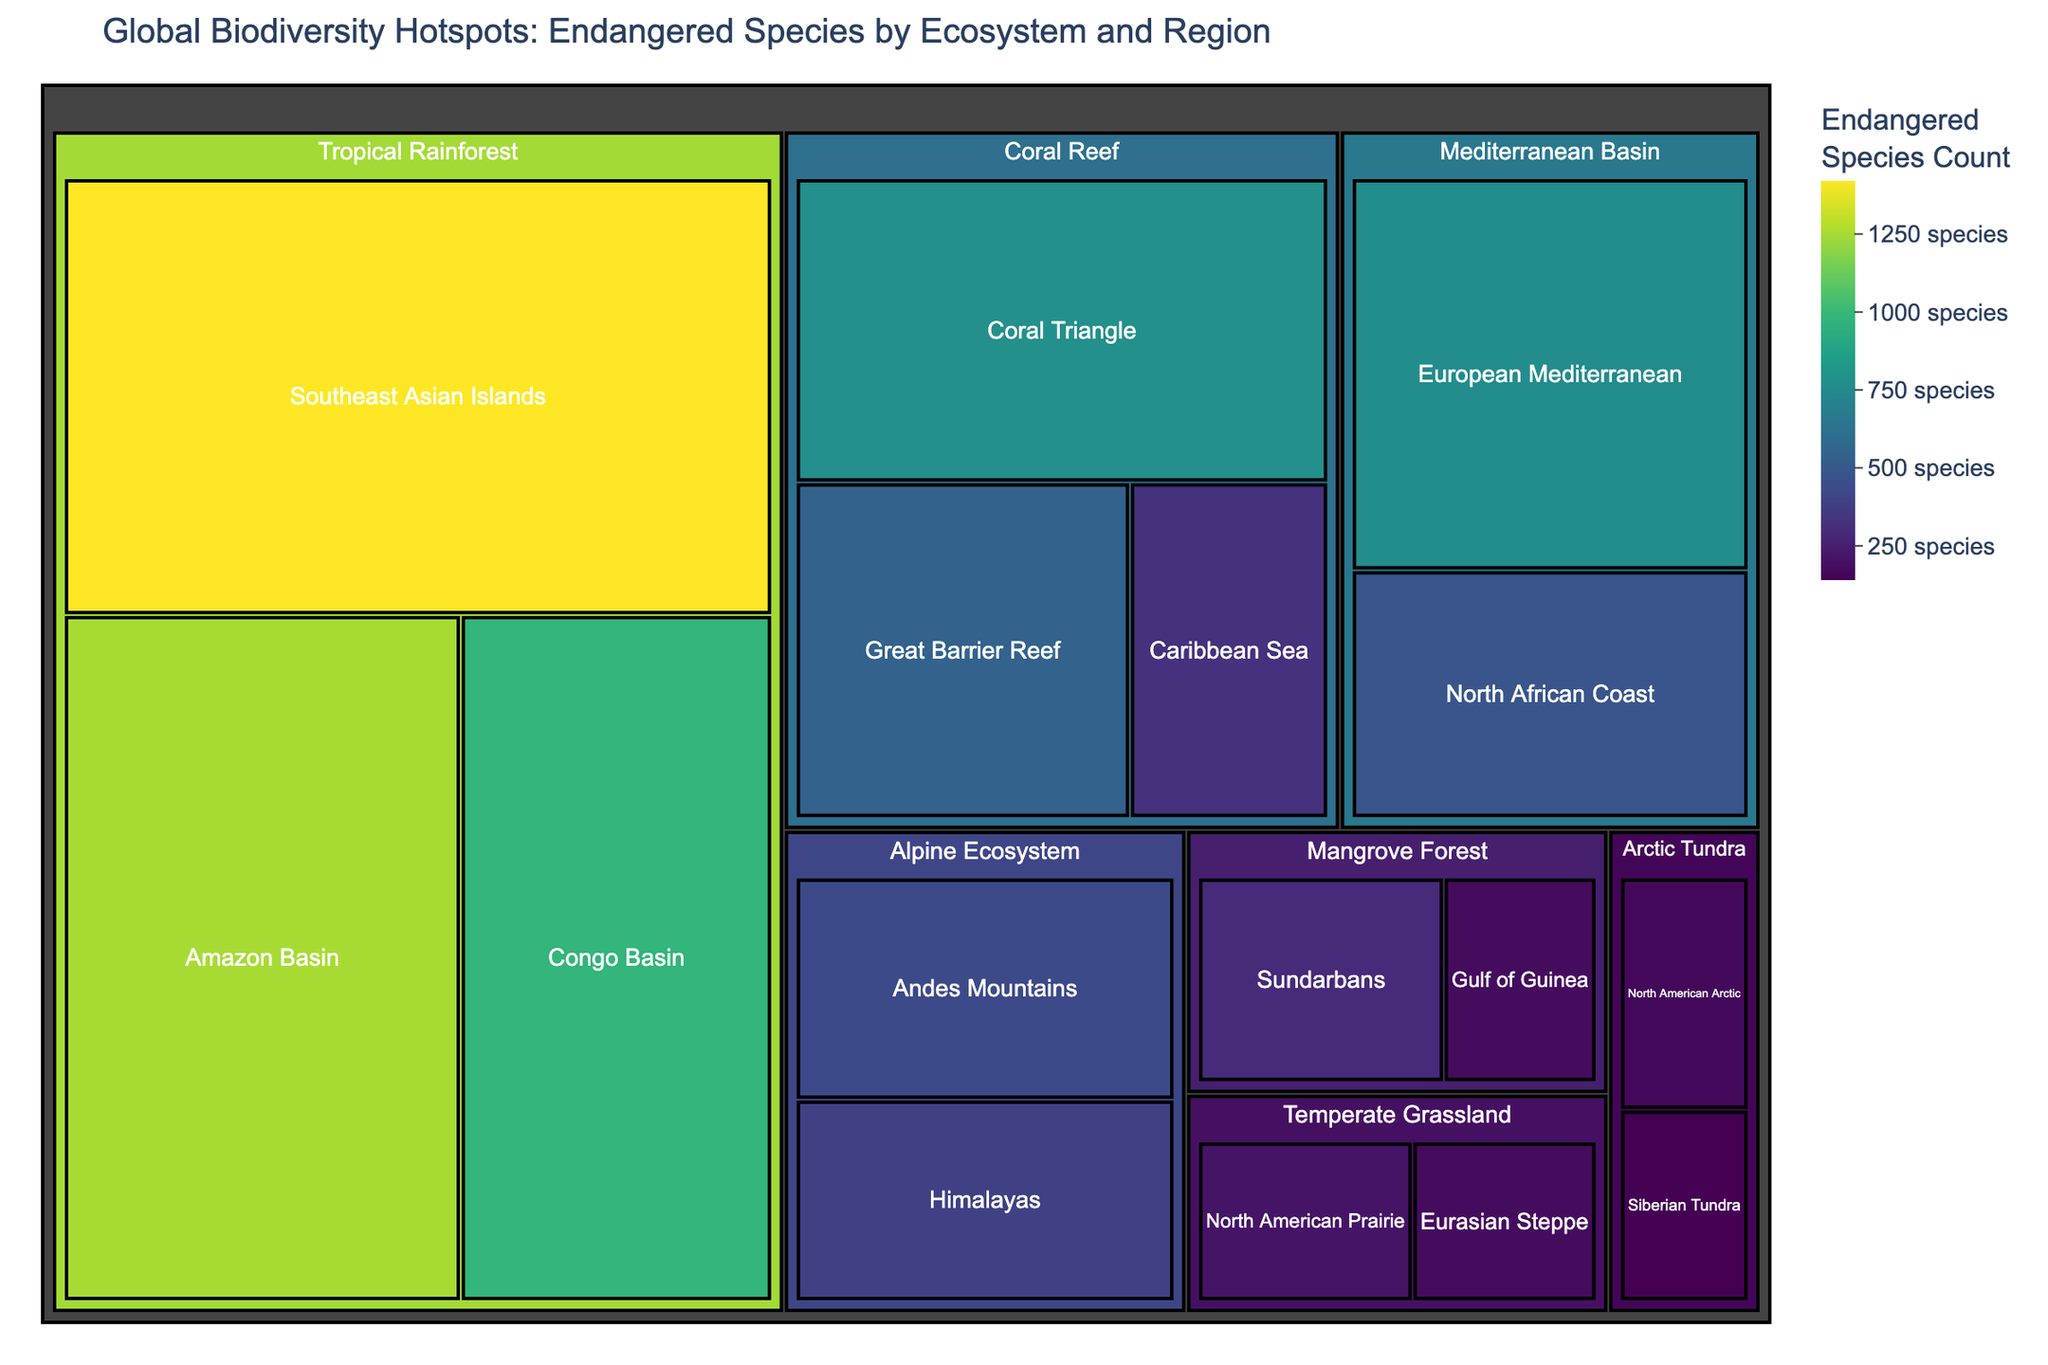What is the title of the treemap? The title of the treemap is displayed prominently at the top of the figure, indicating the subject and focus of the visualization.
Answer: Global Biodiversity Hotspots: Endangered Species by Ecosystem and Region Which region in the Tropical Rainforest ecosystem has the highest number of endangered species? By looking at the blocks within the Tropical Rainforest category, we see that the Southeast Asian Islands region has the largest size and darkest color, indicating the highest count.
Answer: Southeast Asian Islands How many endangered species are found in the Great Barrier Reef? Hovering over or observing the block within the Coral Reef category labeled Great Barrier Reef, we find the count displayed.
Answer: 540 Compare the number of endangered species between the Himalayas and the Andes Mountains within the Alpine Ecosystem. Which region has more endangered species? By examining the respective blocks within the Alpine Ecosystem category, we see that the Andes Mountains block is slightly larger and darker, indicating more endangered species.
Answer: Andes Mountains What is the combined total of endangered species for all regions in the Coral Reef ecosystem? To find the total, add the counts for all regions within Coral Reef: Great Barrier Reef (540), Caribbean Sea (320), and Coral Triangle (780). The sum is 540 + 320 + 780.
Answer: 1640 Which ecosystem has the fewest total number of endangered species across all its regions? By comparing the total area and color intensity of each main category, the Arctic Tundra has the smallest blocks, indicating the lowest count.
Answer: Arctic Tundra How many ecosystems have regions with more than 500 endangered species? By analyzing the color and size intensity, and counting those regions with values greater than 500, we see Tropical Rainforest and Coral Reef ecosystems fit the criteria.
Answer: 2 Within the Mediterranean Basin, which region has fewer endangered species: European Mediterranean or North African Coast? Comparing the blocks within the Mediterranean Basin, the North African Coast block is smaller and lighter, indicating fewer endangered species.
Answer: North African Coast Calculate the average number of endangered species in the regions of the Mangrove Forest. Add the counts for all Mangrove Forest regions: Sundarbans (290) and Gulf of Guinea (180), then divide by the number of regions (2). (290 + 180) / 2 = 235.
Answer: 235 Identify the ecosystem with the greatest disparity in endangered species count between its regions. Comparing each ecosystem, the Tropical Rainforest has the most significant range between the Southeast Asian Islands (1420) and Congo Basin (980), a difference of 440.
Answer: Tropical Rainforest 